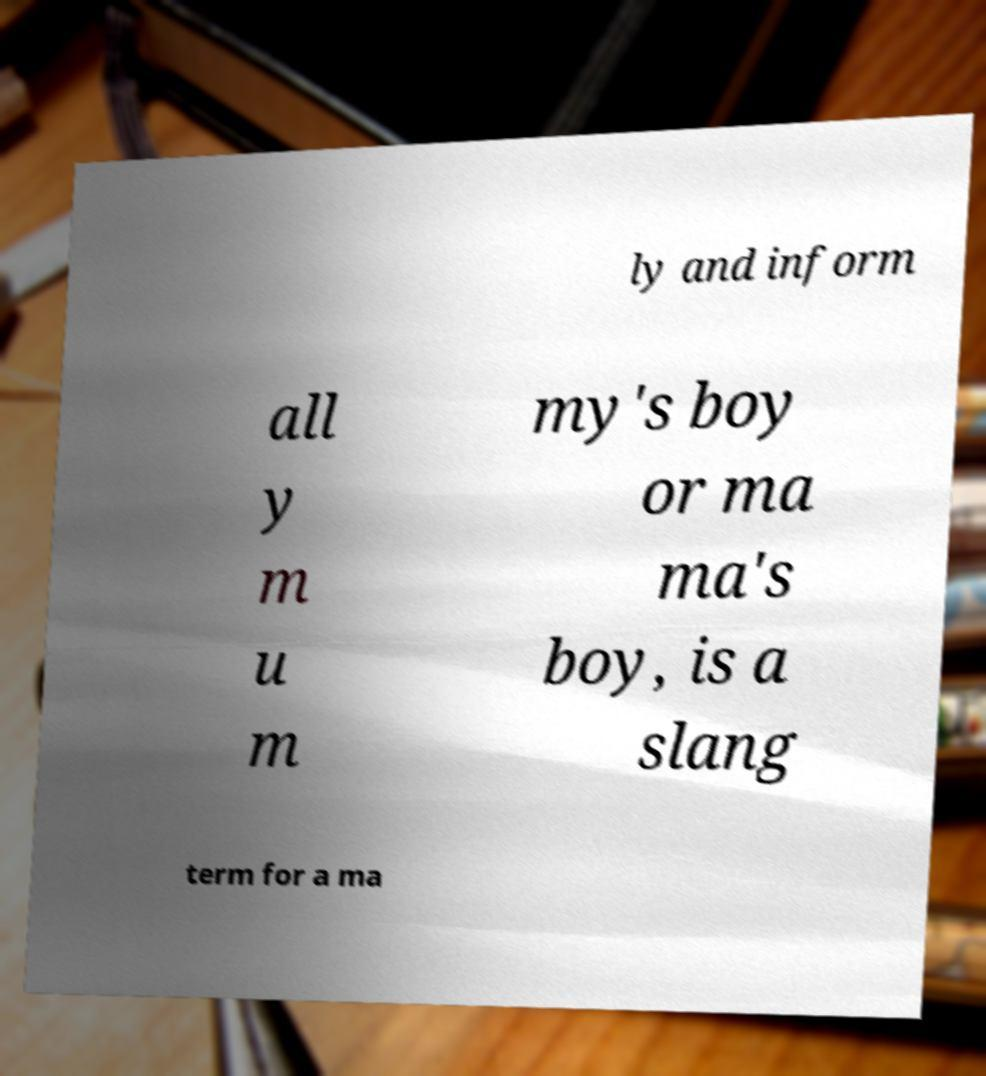Could you assist in decoding the text presented in this image and type it out clearly? ly and inform all y m u m my's boy or ma ma's boy, is a slang term for a ma 